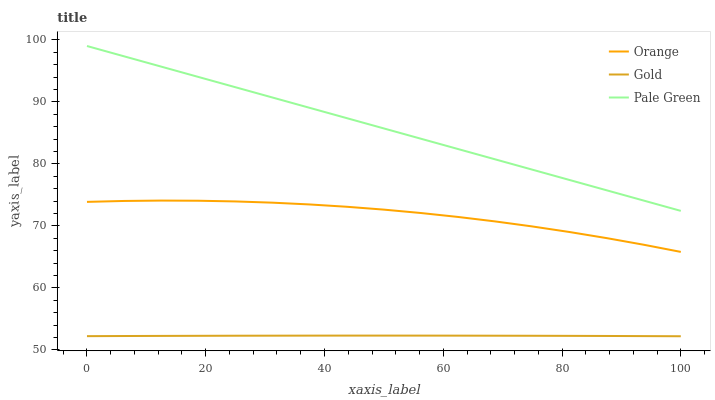Does Pale Green have the minimum area under the curve?
Answer yes or no. No. Does Gold have the maximum area under the curve?
Answer yes or no. No. Is Gold the smoothest?
Answer yes or no. No. Is Gold the roughest?
Answer yes or no. No. Does Pale Green have the lowest value?
Answer yes or no. No. Does Gold have the highest value?
Answer yes or no. No. Is Orange less than Pale Green?
Answer yes or no. Yes. Is Orange greater than Gold?
Answer yes or no. Yes. Does Orange intersect Pale Green?
Answer yes or no. No. 